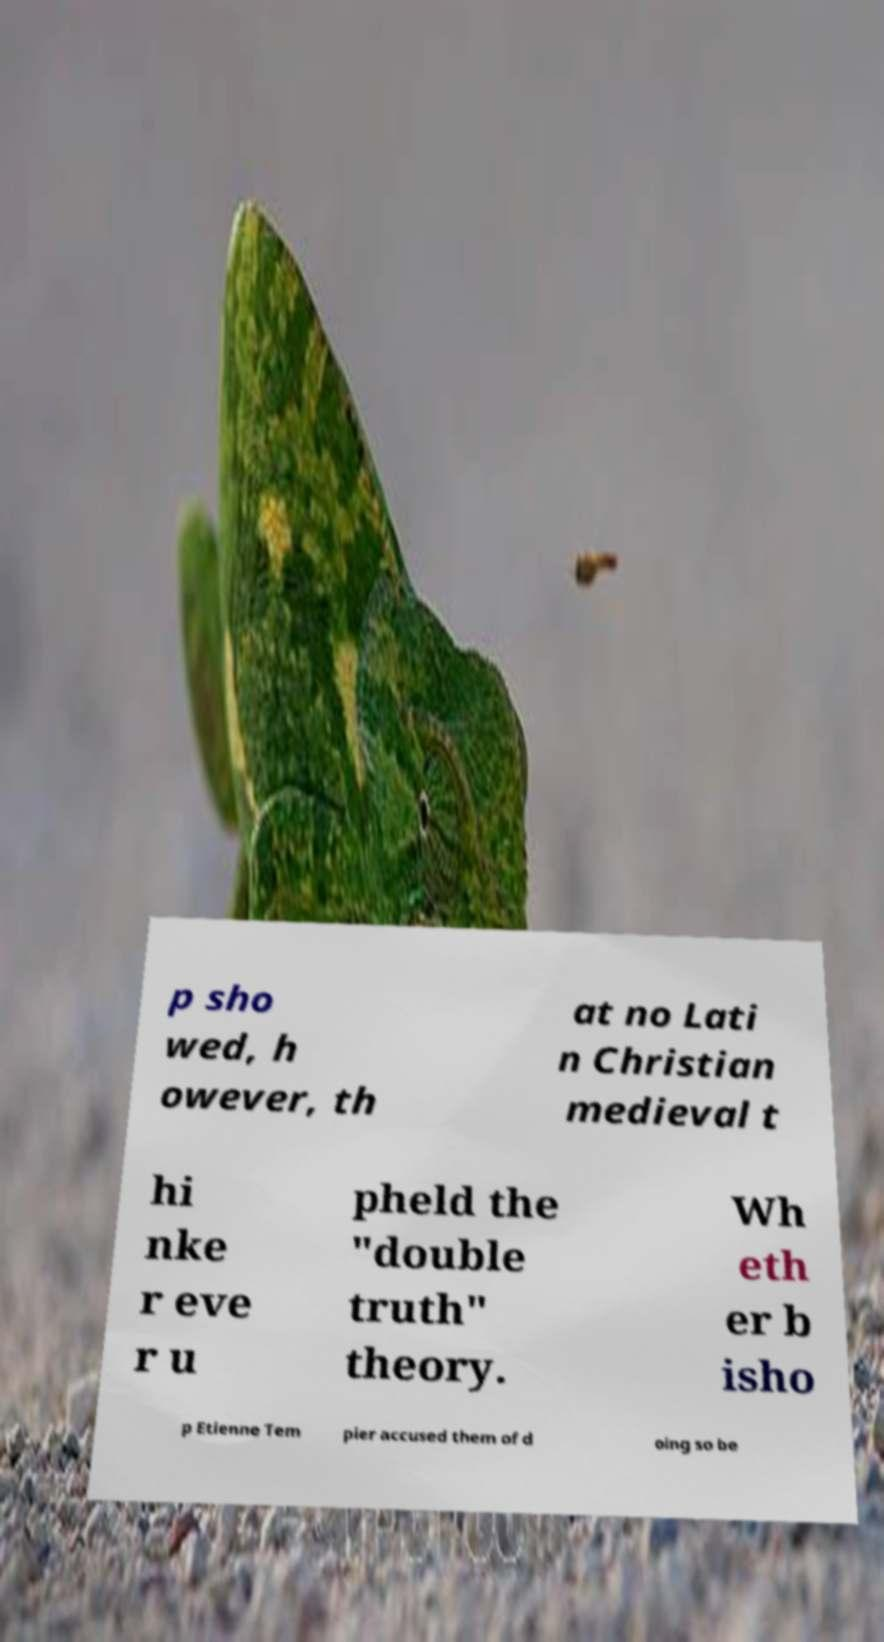Can you accurately transcribe the text from the provided image for me? p sho wed, h owever, th at no Lati n Christian medieval t hi nke r eve r u pheld the "double truth" theory. Wh eth er b isho p Etienne Tem pier accused them of d oing so be 